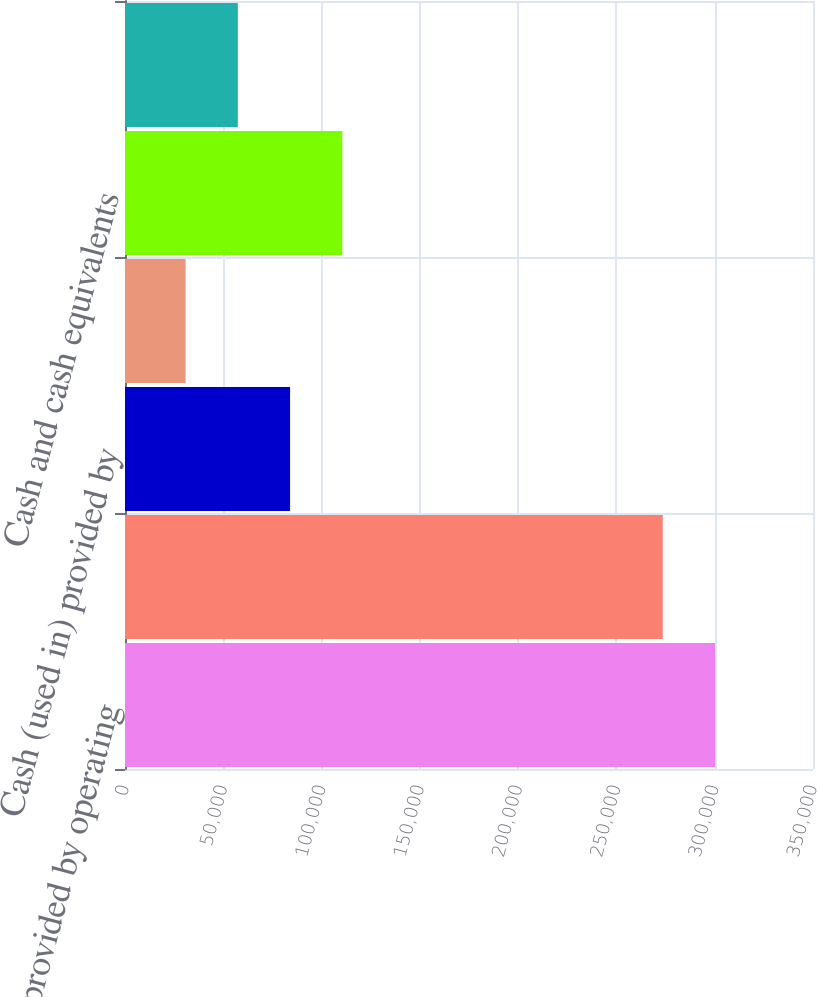Convert chart to OTSL. <chart><loc_0><loc_0><loc_500><loc_500><bar_chart><fcel>Cash provided by operating<fcel>Cash used in investing<fcel>Cash (used in) provided by<fcel>(Decrease) increase in cash<fcel>Cash and cash equivalents<fcel>Cash and cash equivalents end<nl><fcel>300140<fcel>273558<fcel>83981<fcel>30818<fcel>110562<fcel>57399.5<nl></chart> 